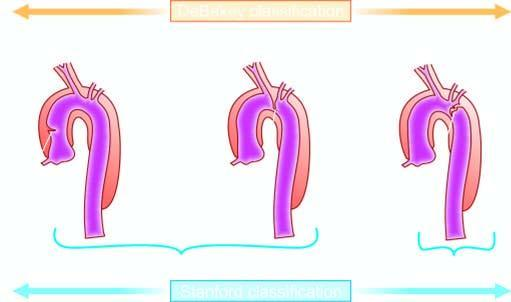what only includes debakey 's type i and ii?
Answer the question using a single word or phrase. Stanford type a involving ascending aorta 